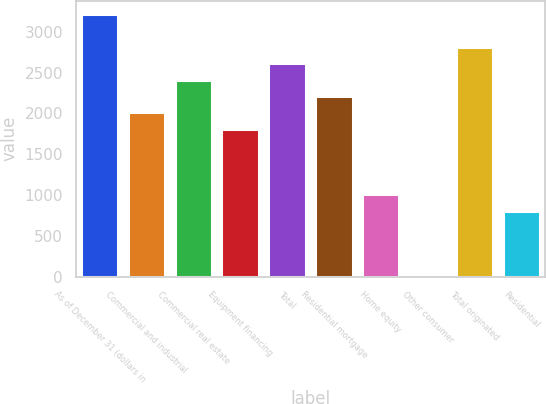Convert chart to OTSL. <chart><loc_0><loc_0><loc_500><loc_500><bar_chart><fcel>As of December 31 (dollars in<fcel>Commercial and industrial<fcel>Commercial real estate<fcel>Equipment financing<fcel>Total<fcel>Residential mortgage<fcel>Home equity<fcel>Other consumer<fcel>Total originated<fcel>Residential<nl><fcel>3217.42<fcel>2011<fcel>2413.14<fcel>1809.93<fcel>2614.21<fcel>2212.07<fcel>1005.65<fcel>0.3<fcel>2815.28<fcel>804.58<nl></chart> 